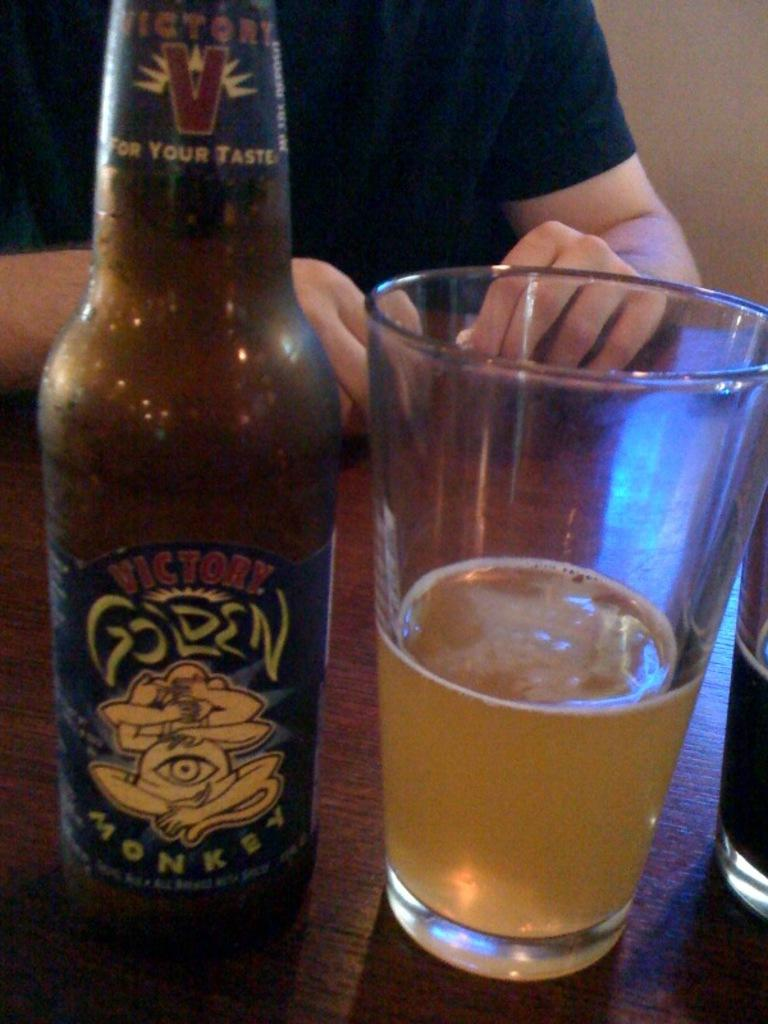<image>
Give a short and clear explanation of the subsequent image. A beer with the label Golden Monkey next to a glass of beer. 